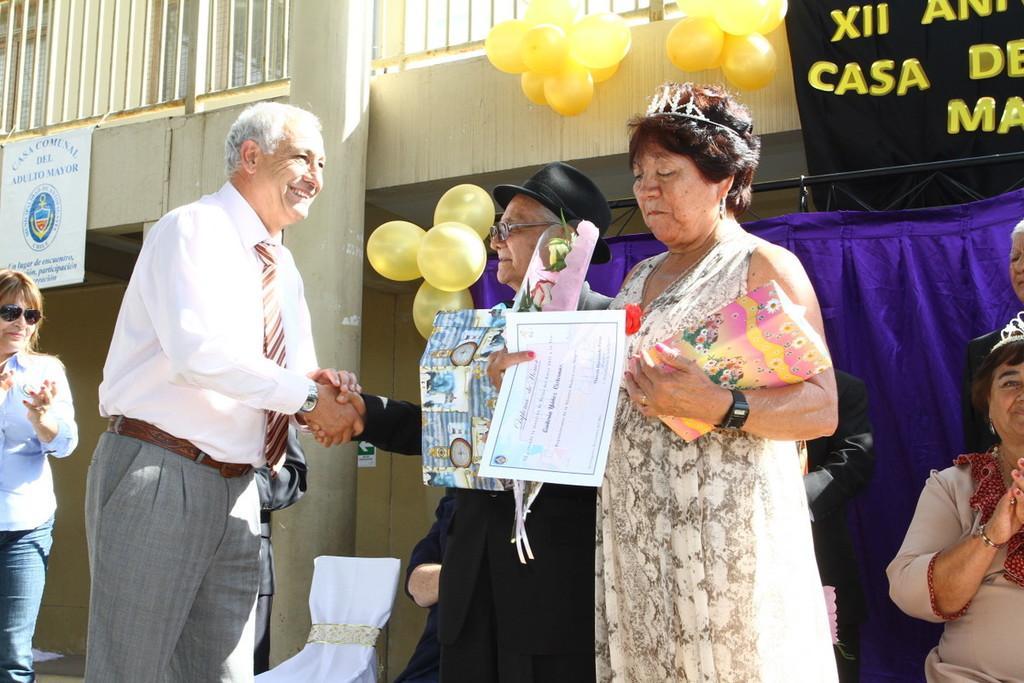Could you give a brief overview of what you see in this image? In front of the image there is a woman holding some objects in her hand, inside the women there are two people shaking hands, behind them there are a few people, there is an empty chair, a banner, there are balloons on the building, on top of the building there is a metal rod fence and there is a display board and a pillar. 